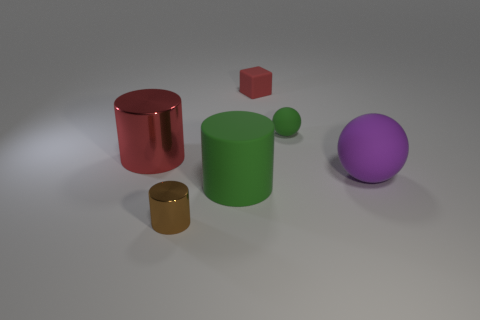Add 3 small matte balls. How many objects exist? 9 Subtract 0 green blocks. How many objects are left? 6 Subtract all cubes. How many objects are left? 5 Subtract all metallic blocks. Subtract all small red matte objects. How many objects are left? 5 Add 3 big things. How many big things are left? 6 Add 6 tiny brown shiny cylinders. How many tiny brown shiny cylinders exist? 7 